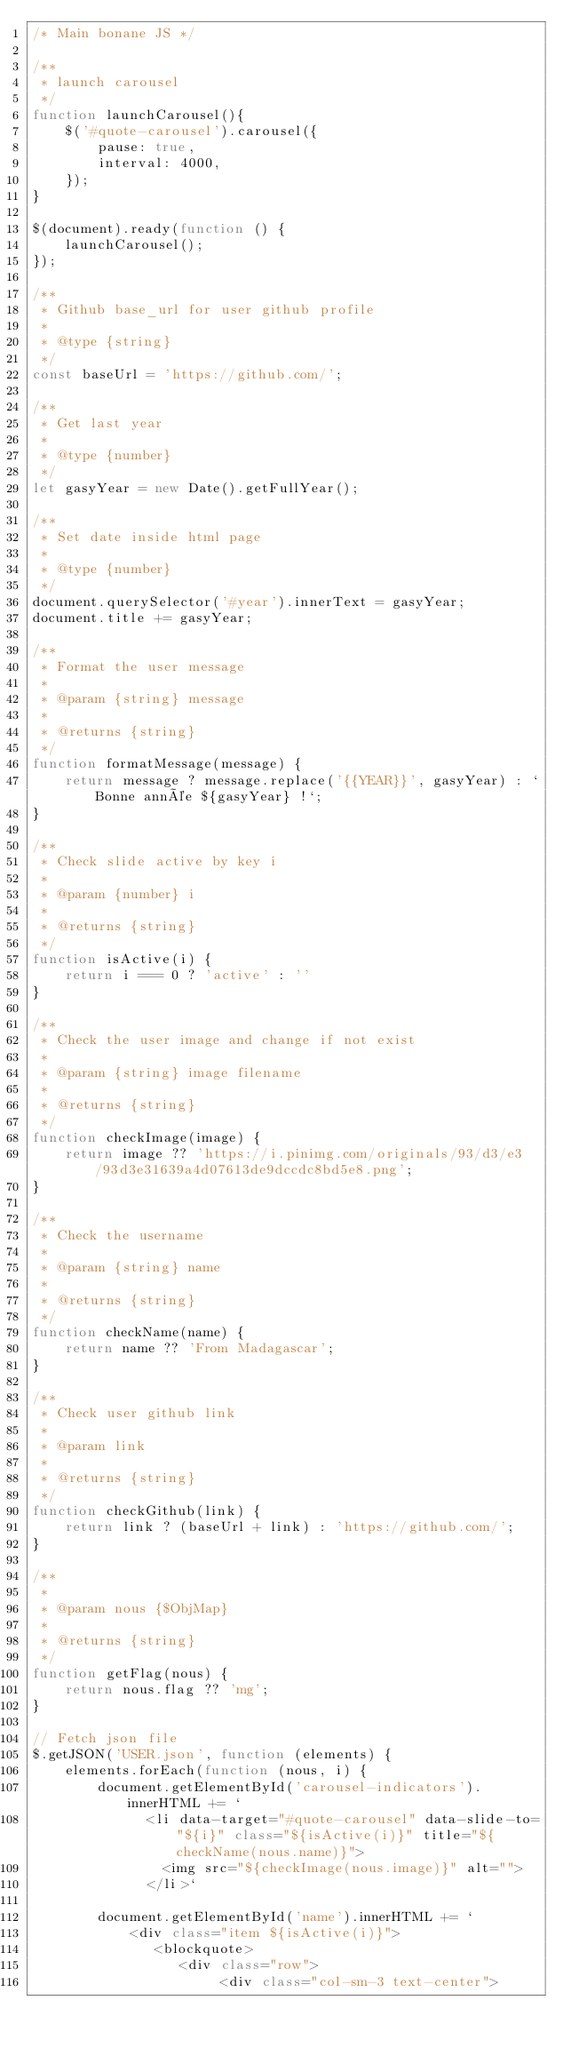Convert code to text. <code><loc_0><loc_0><loc_500><loc_500><_JavaScript_>/* Main bonane JS */

/**
 * launch carousel
 */
function launchCarousel(){
    $('#quote-carousel').carousel({
        pause: true,
        interval: 4000,
    });
}

$(document).ready(function () {
    launchCarousel();
});

/**
 * Github base_url for user github profile
 *
 * @type {string}
 */
const baseUrl = 'https://github.com/';

/**
 * Get last year
 *
 * @type {number}
 */
let gasyYear = new Date().getFullYear();

/**
 * Set date inside html page
 *
 * @type {number}
 */
document.querySelector('#year').innerText = gasyYear;
document.title += gasyYear;

/**
 * Format the user message
 *
 * @param {string} message
 *
 * @returns {string}
 */
function formatMessage(message) {
    return message ? message.replace('{{YEAR}}', gasyYear) : `Bonne année ${gasyYear} !`;
}

/**
 * Check slide active by key i
 *
 * @param {number} i
 *
 * @returns {string}
 */
function isActive(i) {
    return i === 0 ? 'active' : ''
}

/**
 * Check the user image and change if not exist
 *
 * @param {string} image filename
 *
 * @returns {string}
 */
function checkImage(image) {
    return image ?? 'https://i.pinimg.com/originals/93/d3/e3/93d3e31639a4d07613de9dccdc8bd5e8.png';
}

/**
 * Check the username
 *
 * @param {string} name
 *
 * @returns {string}
 */
function checkName(name) {
    return name ?? 'From Madagascar';
}

/**
 * Check user github link
 *
 * @param link
 *
 * @returns {string}
 */
function checkGithub(link) {
    return link ? (baseUrl + link) : 'https://github.com/';
}

/**
 *
 * @param nous {$ObjMap}
 *
 * @returns {string}
 */
function getFlag(nous) {
    return nous.flag ?? 'mg';
}

// Fetch json file
$.getJSON('USER.json', function (elements) {
    elements.forEach(function (nous, i) {
        document.getElementById('carousel-indicators').innerHTML += `
              <li data-target="#quote-carousel" data-slide-to="${i}" class="${isActive(i)}" title="${checkName(nous.name)}">
                <img src="${checkImage(nous.image)}" alt="">
              </li>`

        document.getElementById('name').innerHTML += `
            <div class="item ${isActive(i)}">
               <blockquote>
                  <div class="row">
                       <div class="col-sm-3 text-center"></code> 